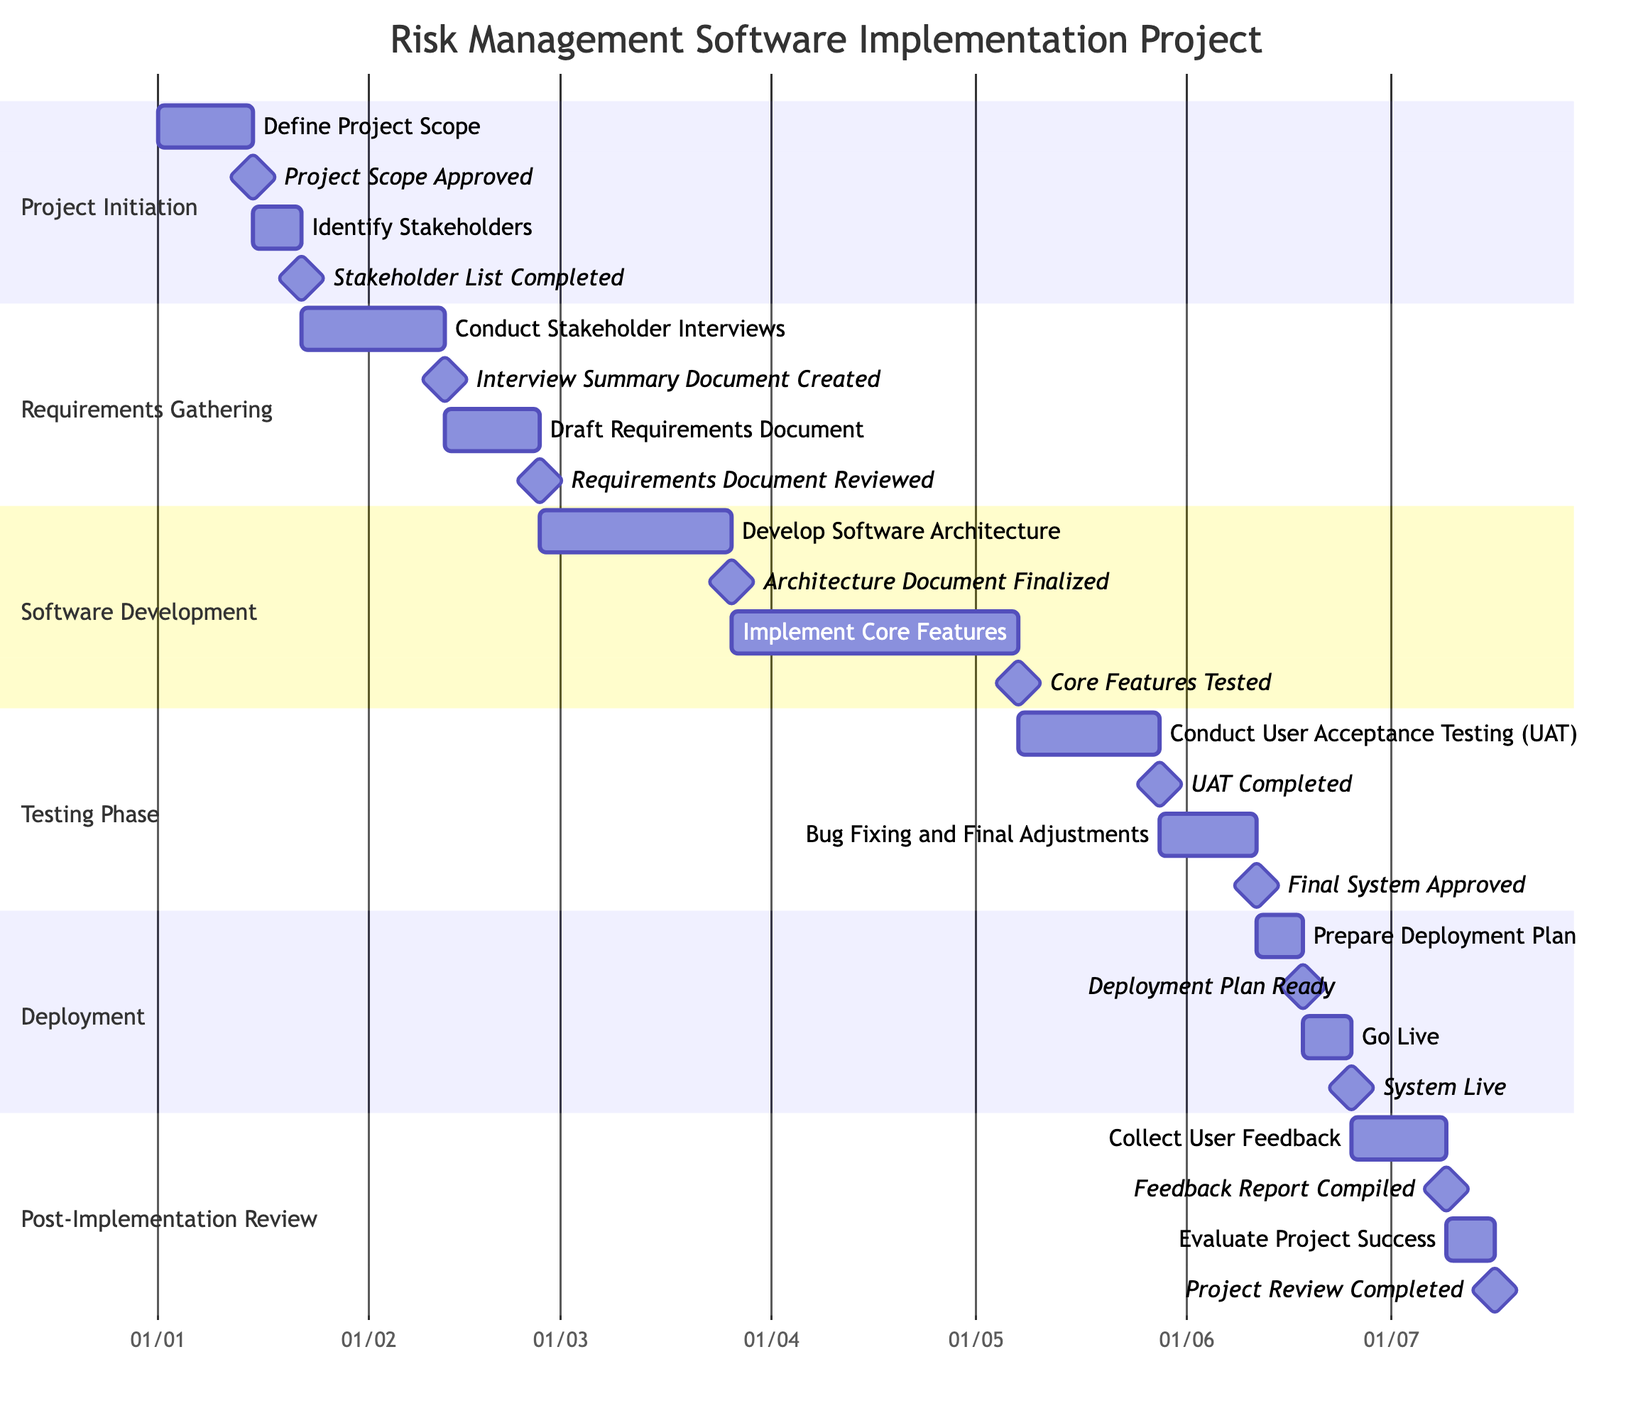What is the duration of the "Define Project Scope" task? The duration of the "Define Project Scope" task is clearly shown in the diagram alongside the task, marked as "2 weeks".
Answer: 2 weeks How many tasks are in the "Testing Phase"? The "Testing Phase" section contains two tasks: "Conduct User Acceptance Testing (UAT)" and "Bug Fixing and Final Adjustments". The count of these tasks gives us the answer.
Answer: 2 What milestone follows the "Draft Requirements Document"? The next milestone listed immediately after the task "Draft Requirements Document" is "Requirements Document Reviewed". This can be found by looking at the connection between the task and the associated milestone in the diagram.
Answer: Requirements Document Reviewed When does the "Go Live" task start? The "Go Live" task starts on June 18, 2023, which can be identified by checking the timeline where this task is positioned in the Gantt Chart.
Answer: 2023-06-18 What is the milestone for "Conduct User Acceptance Testing (UAT)"? The milestone associated with the task "Conduct User Acceptance Testing (UAT)" is "UAT Completed". This can be seen directly connected to the UAT task in the diagram.
Answer: UAT Completed What is the total duration of the "Post-Implementation Review" phase? The "Post-Implementation Review" phase includes two tasks: "Collect User Feedback" (2 weeks) and "Evaluate Project Success" (1 week). Adding these together gives a total duration of 3 weeks for this phase.
Answer: 3 weeks Which task has the longest duration in the project? The task "Implement Core Features" has the longest duration of 6 weeks, which is identified by comparing the durations of all tasks presented in the diagram.
Answer: 6 weeks How many milestones are there in the "Software Development" phase? In the "Software Development" phase, there are two milestones listed: "Architecture Document Finalized" and "Core Features Tested". Counting these gives the total number of milestones in this phase.
Answer: 2 